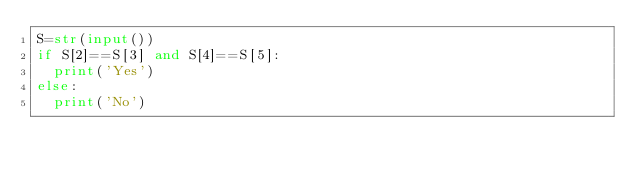Convert code to text. <code><loc_0><loc_0><loc_500><loc_500><_Python_>S=str(input())
if S[2]==S[3] and S[4]==S[5]:
  print('Yes')
else:
  print('No')</code> 